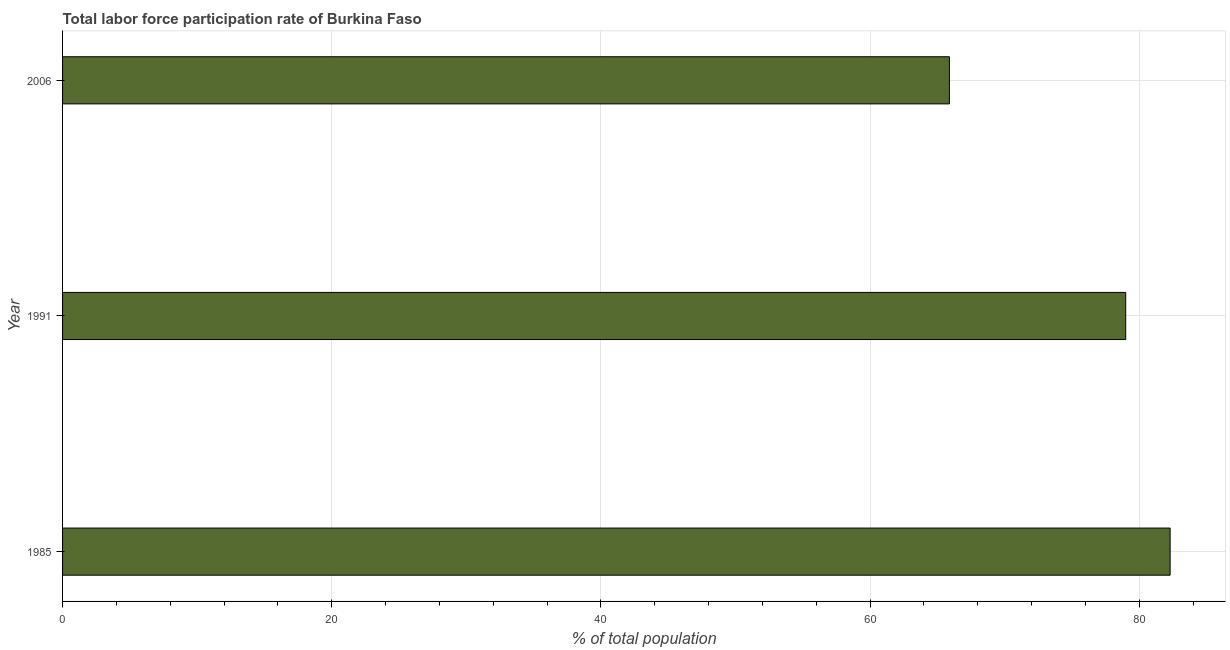What is the title of the graph?
Offer a terse response. Total labor force participation rate of Burkina Faso. What is the label or title of the X-axis?
Offer a very short reply. % of total population. What is the total labor force participation rate in 2006?
Your answer should be very brief. 65.9. Across all years, what is the maximum total labor force participation rate?
Your response must be concise. 82.3. Across all years, what is the minimum total labor force participation rate?
Keep it short and to the point. 65.9. In which year was the total labor force participation rate maximum?
Provide a short and direct response. 1985. What is the sum of the total labor force participation rate?
Provide a short and direct response. 227.2. What is the difference between the total labor force participation rate in 1985 and 2006?
Make the answer very short. 16.4. What is the average total labor force participation rate per year?
Your response must be concise. 75.73. What is the median total labor force participation rate?
Provide a short and direct response. 79. What is the ratio of the total labor force participation rate in 1985 to that in 2006?
Ensure brevity in your answer.  1.25. Is the difference between the total labor force participation rate in 1991 and 2006 greater than the difference between any two years?
Your answer should be very brief. No. What is the difference between the highest and the second highest total labor force participation rate?
Your answer should be very brief. 3.3. Is the sum of the total labor force participation rate in 1985 and 1991 greater than the maximum total labor force participation rate across all years?
Your answer should be compact. Yes. What is the difference between the highest and the lowest total labor force participation rate?
Provide a succinct answer. 16.4. Are all the bars in the graph horizontal?
Your answer should be compact. Yes. What is the difference between two consecutive major ticks on the X-axis?
Give a very brief answer. 20. What is the % of total population in 1985?
Give a very brief answer. 82.3. What is the % of total population in 1991?
Your answer should be very brief. 79. What is the % of total population of 2006?
Your response must be concise. 65.9. What is the difference between the % of total population in 1985 and 2006?
Your answer should be very brief. 16.4. What is the difference between the % of total population in 1991 and 2006?
Your response must be concise. 13.1. What is the ratio of the % of total population in 1985 to that in 1991?
Your answer should be compact. 1.04. What is the ratio of the % of total population in 1985 to that in 2006?
Keep it short and to the point. 1.25. What is the ratio of the % of total population in 1991 to that in 2006?
Make the answer very short. 1.2. 